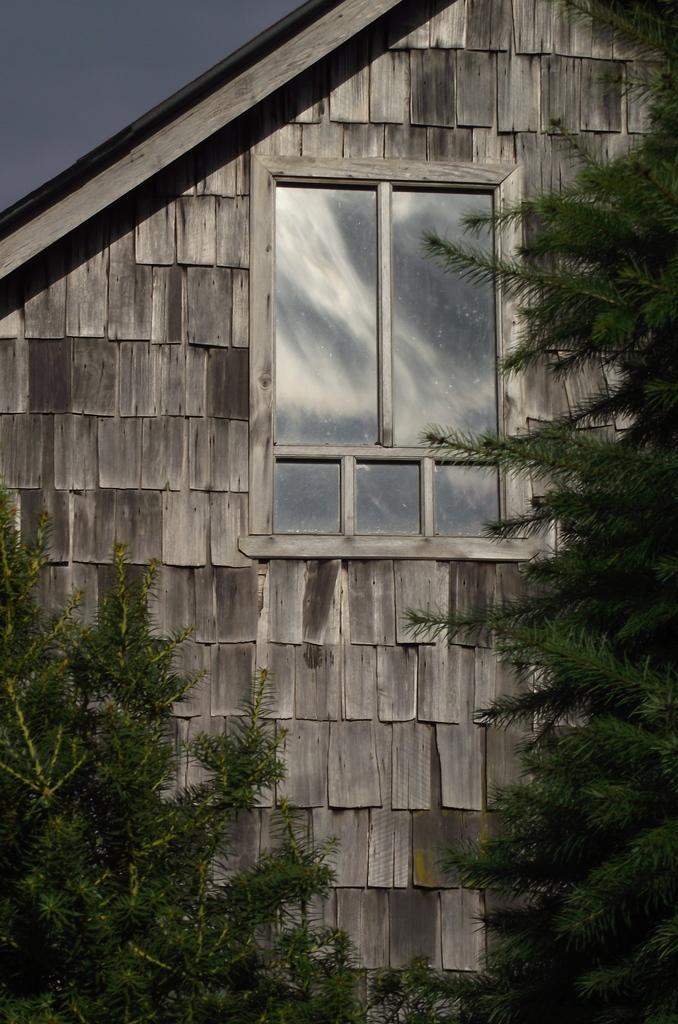Describe this image in one or two sentences. In the image in the center,we can see one wooden house,window and trees. 